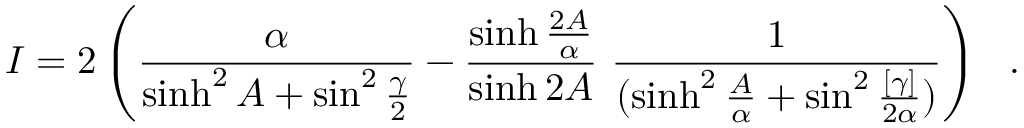Convert formula to latex. <formula><loc_0><loc_0><loc_500><loc_500>I = 2 \left ( { \frac { \alpha } { \sinh ^ { 2 } A + \sin ^ { 2 } { \frac { \gamma } { 2 } } } } - { \frac { \sinh { \frac { 2 A } { \alpha } } } { \sinh { 2 A } } } { \frac { 1 } { ( \sinh ^ { 2 } { \frac { A } { \alpha } } + \sin ^ { 2 } { \frac { [ \gamma ] } { 2 \alpha } } ) } } \right ) .</formula> 